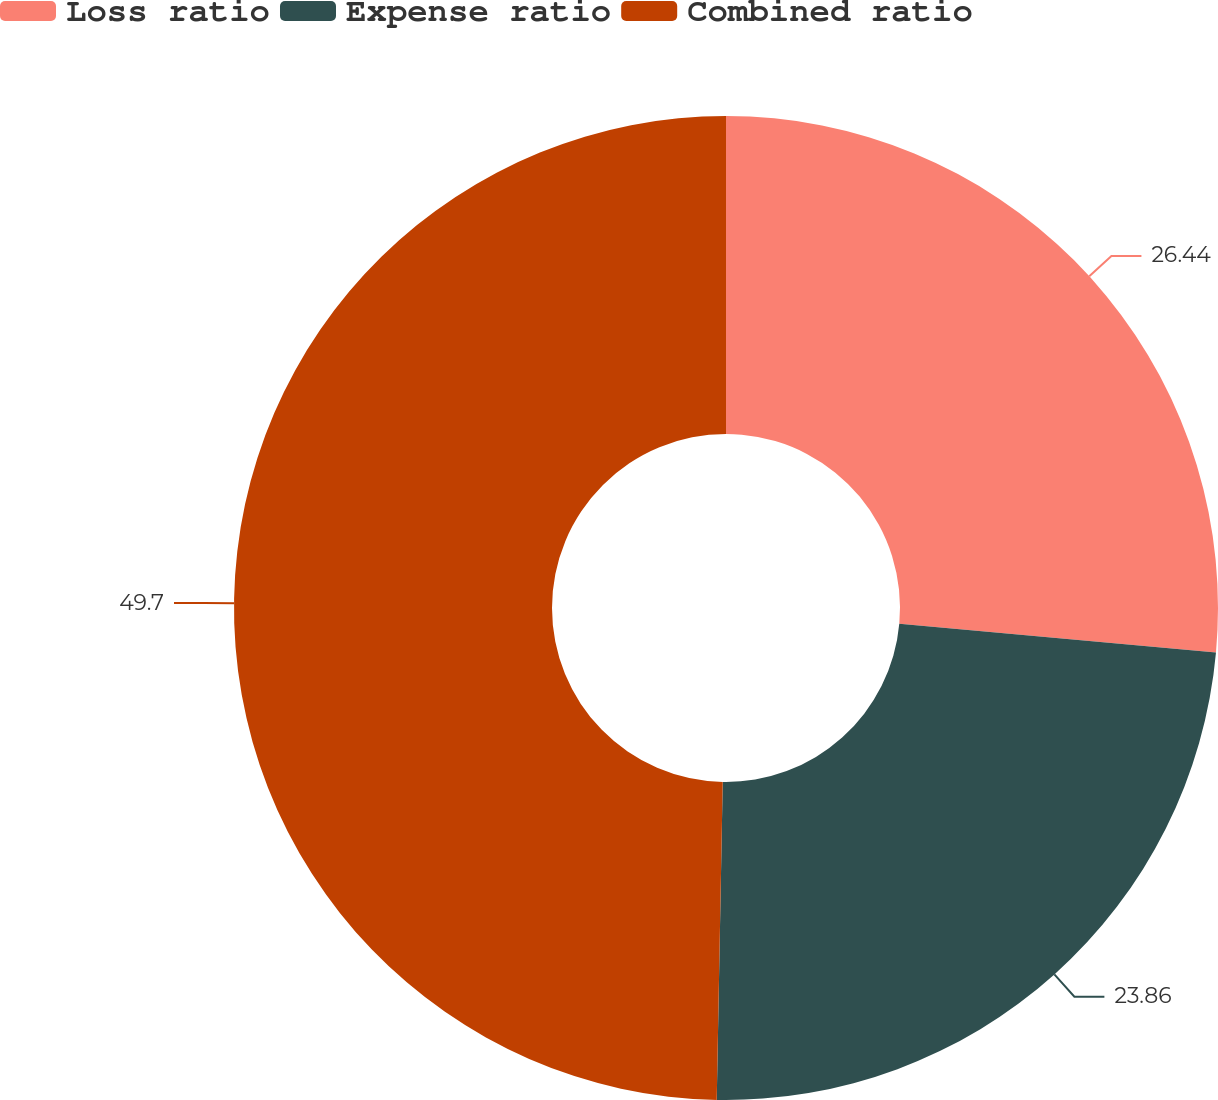<chart> <loc_0><loc_0><loc_500><loc_500><pie_chart><fcel>Loss ratio<fcel>Expense ratio<fcel>Combined ratio<nl><fcel>26.44%<fcel>23.86%<fcel>49.7%<nl></chart> 